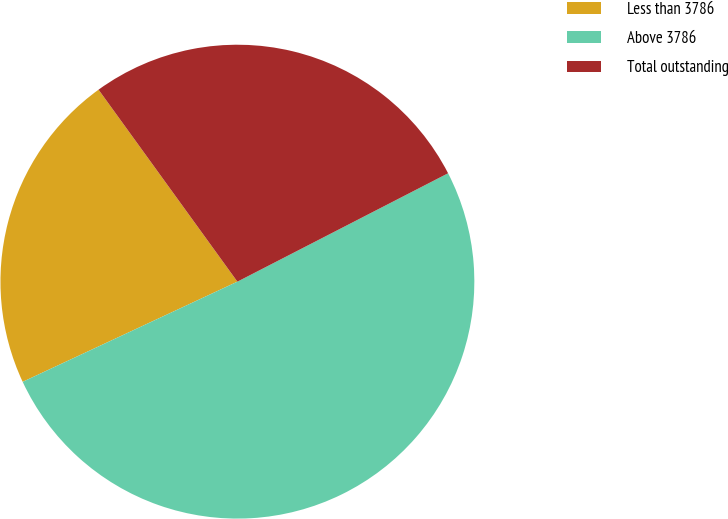Convert chart. <chart><loc_0><loc_0><loc_500><loc_500><pie_chart><fcel>Less than 3786<fcel>Above 3786<fcel>Total outstanding<nl><fcel>21.98%<fcel>50.61%<fcel>27.4%<nl></chart> 